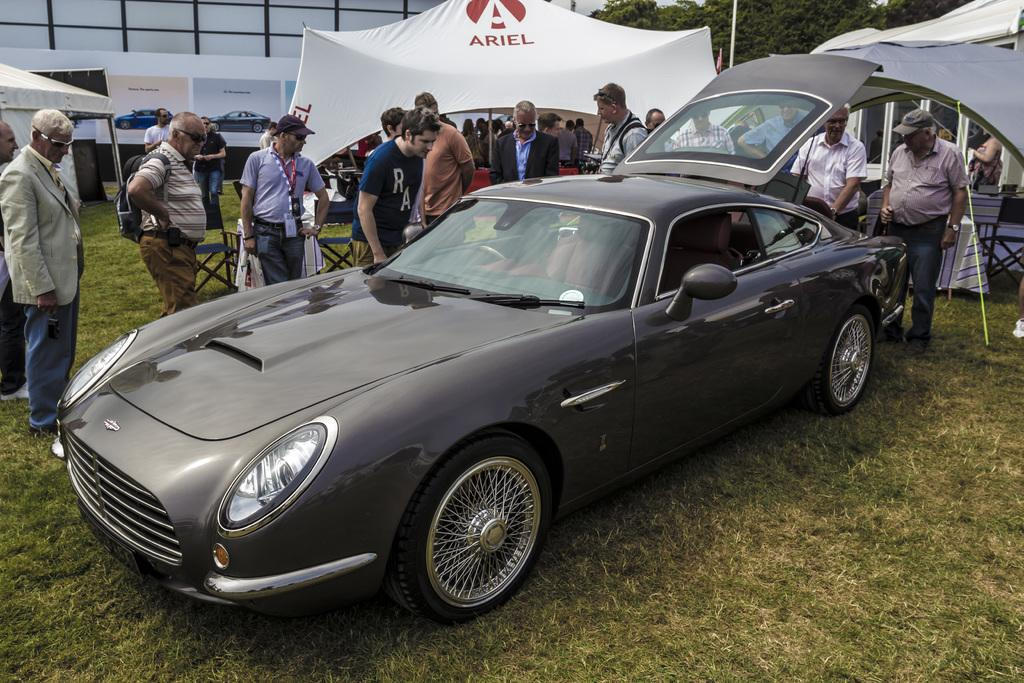What is the main object in the image? There is a car in the grass. Are there any people present in the image? Yes, there are people standing in the image. What type of structures can be seen in the image? There are tents in the image. What type of natural environment is visible in the image? There are trees in the image. What type of grain is being harvested in the image? There is no grain present in the image; it features a car in the grass, people, tents, and trees. Where is the spot where the people are playing in the image? There is no mention of people playing in the image; the people are simply standing. 